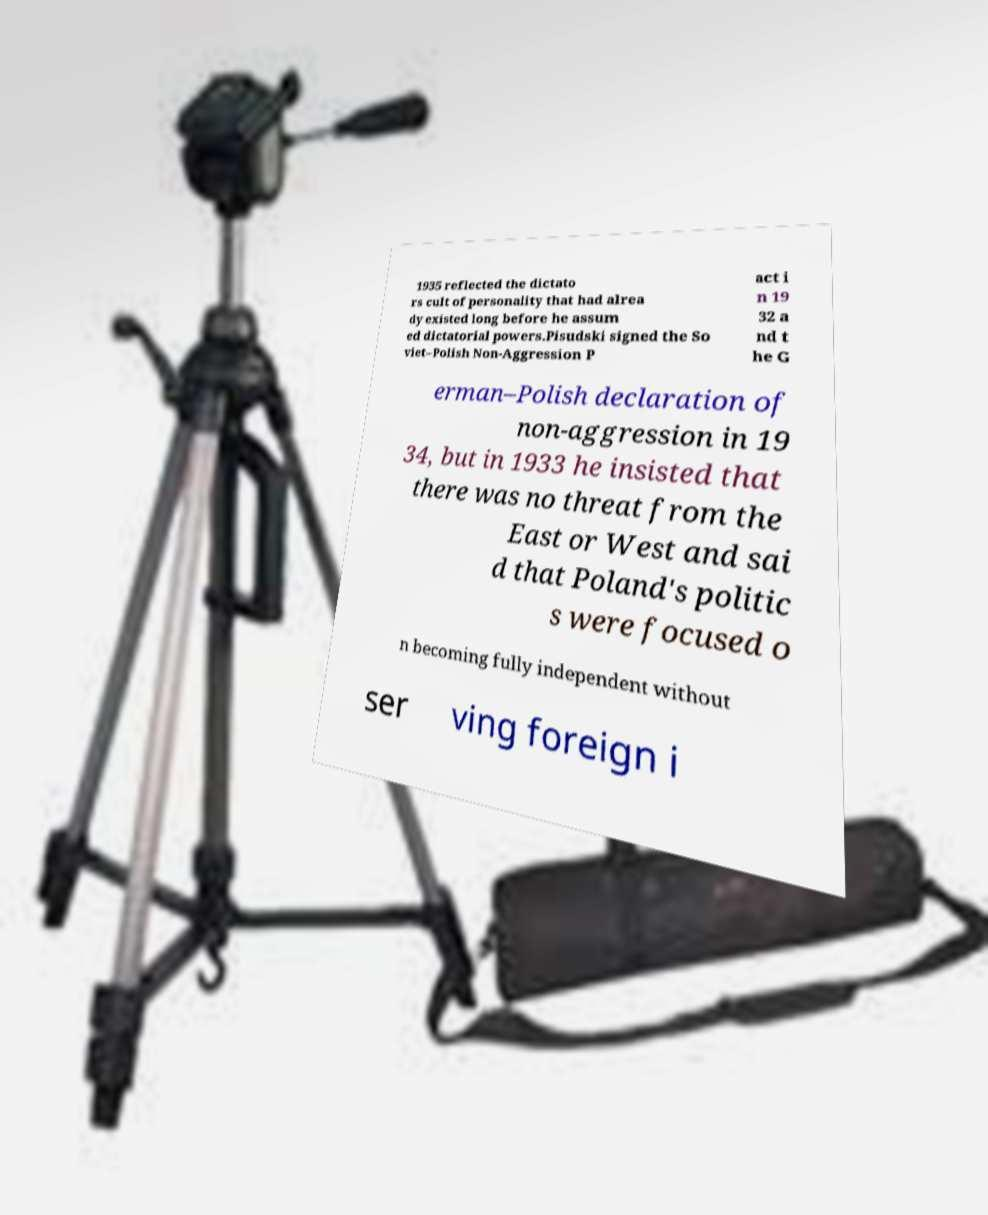Could you assist in decoding the text presented in this image and type it out clearly? 1935 reflected the dictato rs cult of personality that had alrea dy existed long before he assum ed dictatorial powers.Pisudski signed the So viet–Polish Non-Aggression P act i n 19 32 a nd t he G erman–Polish declaration of non-aggression in 19 34, but in 1933 he insisted that there was no threat from the East or West and sai d that Poland's politic s were focused o n becoming fully independent without ser ving foreign i 